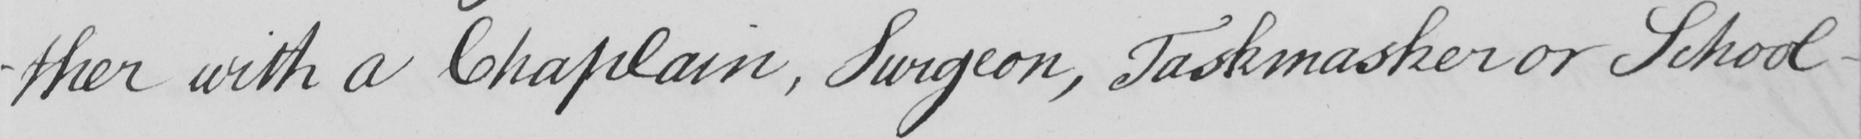Please transcribe the handwritten text in this image. -ther with a Chaplain , Surgeon , Taskmaster or School- 